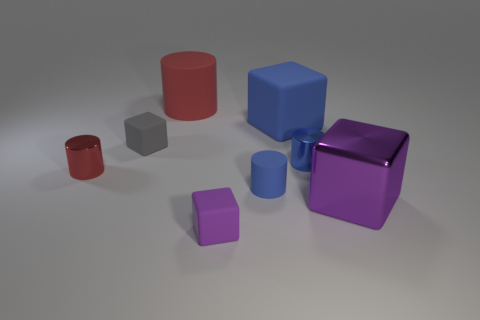Add 1 gray cubes. How many objects exist? 9 Subtract all tiny metallic cylinders. Subtract all big rubber things. How many objects are left? 4 Add 2 blue things. How many blue things are left? 5 Add 5 tiny red things. How many tiny red things exist? 6 Subtract 0 brown spheres. How many objects are left? 8 